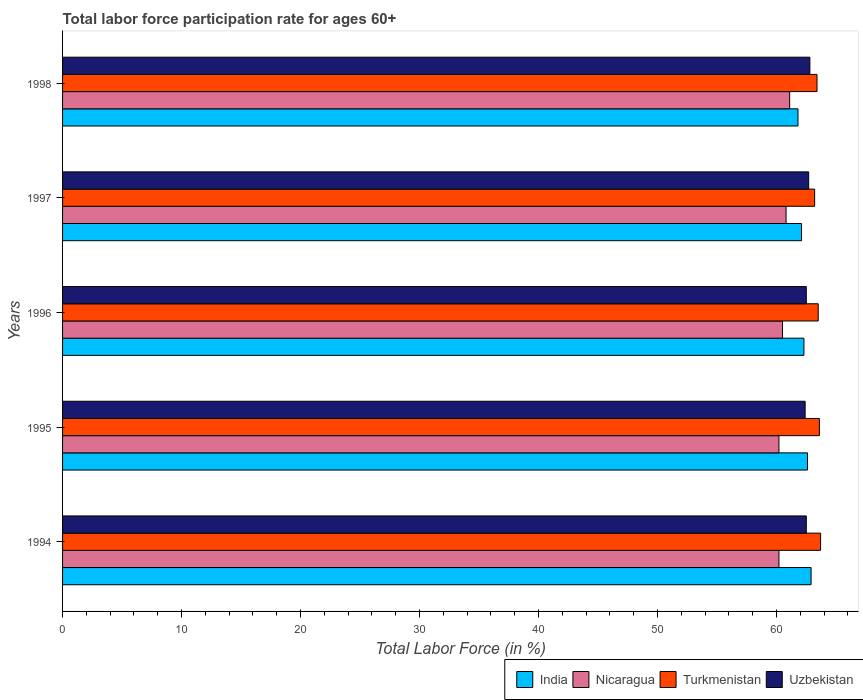How many different coloured bars are there?
Offer a terse response. 4. How many groups of bars are there?
Your answer should be compact. 5. Are the number of bars on each tick of the Y-axis equal?
Your answer should be very brief. Yes. What is the label of the 3rd group of bars from the top?
Give a very brief answer. 1996. In how many cases, is the number of bars for a given year not equal to the number of legend labels?
Your answer should be compact. 0. What is the labor force participation rate in Uzbekistan in 1996?
Offer a very short reply. 62.5. Across all years, what is the maximum labor force participation rate in India?
Your response must be concise. 62.9. Across all years, what is the minimum labor force participation rate in India?
Provide a short and direct response. 61.8. In which year was the labor force participation rate in Nicaragua maximum?
Ensure brevity in your answer.  1998. In which year was the labor force participation rate in Uzbekistan minimum?
Keep it short and to the point. 1995. What is the total labor force participation rate in India in the graph?
Make the answer very short. 311.7. What is the difference between the labor force participation rate in Uzbekistan in 1994 and that in 1995?
Keep it short and to the point. 0.1. What is the difference between the labor force participation rate in Nicaragua in 1996 and the labor force participation rate in Turkmenistan in 1998?
Make the answer very short. -2.9. What is the average labor force participation rate in Uzbekistan per year?
Keep it short and to the point. 62.58. In the year 1995, what is the difference between the labor force participation rate in Uzbekistan and labor force participation rate in Nicaragua?
Give a very brief answer. 2.2. In how many years, is the labor force participation rate in India greater than 56 %?
Give a very brief answer. 5. What is the ratio of the labor force participation rate in Nicaragua in 1994 to that in 1997?
Make the answer very short. 0.99. Is the labor force participation rate in India in 1995 less than that in 1997?
Keep it short and to the point. No. What is the difference between the highest and the second highest labor force participation rate in Uzbekistan?
Your response must be concise. 0.1. What is the difference between the highest and the lowest labor force participation rate in Uzbekistan?
Provide a succinct answer. 0.4. In how many years, is the labor force participation rate in India greater than the average labor force participation rate in India taken over all years?
Offer a very short reply. 2. What does the 1st bar from the top in 1994 represents?
Your answer should be compact. Uzbekistan. What does the 2nd bar from the bottom in 1995 represents?
Keep it short and to the point. Nicaragua. How many bars are there?
Your answer should be compact. 20. Does the graph contain grids?
Keep it short and to the point. No. Where does the legend appear in the graph?
Keep it short and to the point. Bottom right. How are the legend labels stacked?
Offer a terse response. Horizontal. What is the title of the graph?
Ensure brevity in your answer.  Total labor force participation rate for ages 60+. What is the label or title of the X-axis?
Keep it short and to the point. Total Labor Force (in %). What is the label or title of the Y-axis?
Your answer should be compact. Years. What is the Total Labor Force (in %) of India in 1994?
Your answer should be compact. 62.9. What is the Total Labor Force (in %) of Nicaragua in 1994?
Provide a short and direct response. 60.2. What is the Total Labor Force (in %) in Turkmenistan in 1994?
Your answer should be very brief. 63.7. What is the Total Labor Force (in %) of Uzbekistan in 1994?
Keep it short and to the point. 62.5. What is the Total Labor Force (in %) of India in 1995?
Your answer should be compact. 62.6. What is the Total Labor Force (in %) of Nicaragua in 1995?
Your answer should be very brief. 60.2. What is the Total Labor Force (in %) in Turkmenistan in 1995?
Provide a short and direct response. 63.6. What is the Total Labor Force (in %) of Uzbekistan in 1995?
Your answer should be compact. 62.4. What is the Total Labor Force (in %) in India in 1996?
Your answer should be very brief. 62.3. What is the Total Labor Force (in %) of Nicaragua in 1996?
Ensure brevity in your answer.  60.5. What is the Total Labor Force (in %) in Turkmenistan in 1996?
Give a very brief answer. 63.5. What is the Total Labor Force (in %) in Uzbekistan in 1996?
Give a very brief answer. 62.5. What is the Total Labor Force (in %) in India in 1997?
Your answer should be compact. 62.1. What is the Total Labor Force (in %) of Nicaragua in 1997?
Your answer should be very brief. 60.8. What is the Total Labor Force (in %) of Turkmenistan in 1997?
Your answer should be compact. 63.2. What is the Total Labor Force (in %) of Uzbekistan in 1997?
Your answer should be compact. 62.7. What is the Total Labor Force (in %) of India in 1998?
Offer a terse response. 61.8. What is the Total Labor Force (in %) of Nicaragua in 1998?
Give a very brief answer. 61.1. What is the Total Labor Force (in %) of Turkmenistan in 1998?
Make the answer very short. 63.4. What is the Total Labor Force (in %) in Uzbekistan in 1998?
Your answer should be very brief. 62.8. Across all years, what is the maximum Total Labor Force (in %) in India?
Ensure brevity in your answer.  62.9. Across all years, what is the maximum Total Labor Force (in %) of Nicaragua?
Make the answer very short. 61.1. Across all years, what is the maximum Total Labor Force (in %) of Turkmenistan?
Your response must be concise. 63.7. Across all years, what is the maximum Total Labor Force (in %) of Uzbekistan?
Your response must be concise. 62.8. Across all years, what is the minimum Total Labor Force (in %) of India?
Give a very brief answer. 61.8. Across all years, what is the minimum Total Labor Force (in %) of Nicaragua?
Your response must be concise. 60.2. Across all years, what is the minimum Total Labor Force (in %) of Turkmenistan?
Give a very brief answer. 63.2. Across all years, what is the minimum Total Labor Force (in %) of Uzbekistan?
Keep it short and to the point. 62.4. What is the total Total Labor Force (in %) in India in the graph?
Offer a terse response. 311.7. What is the total Total Labor Force (in %) in Nicaragua in the graph?
Your answer should be very brief. 302.8. What is the total Total Labor Force (in %) in Turkmenistan in the graph?
Ensure brevity in your answer.  317.4. What is the total Total Labor Force (in %) of Uzbekistan in the graph?
Keep it short and to the point. 312.9. What is the difference between the Total Labor Force (in %) of Nicaragua in 1994 and that in 1995?
Your answer should be compact. 0. What is the difference between the Total Labor Force (in %) in Uzbekistan in 1994 and that in 1995?
Your answer should be compact. 0.1. What is the difference between the Total Labor Force (in %) of Nicaragua in 1994 and that in 1996?
Offer a terse response. -0.3. What is the difference between the Total Labor Force (in %) of Turkmenistan in 1994 and that in 1996?
Offer a terse response. 0.2. What is the difference between the Total Labor Force (in %) in Uzbekistan in 1994 and that in 1996?
Your answer should be compact. 0. What is the difference between the Total Labor Force (in %) in India in 1994 and that in 1997?
Give a very brief answer. 0.8. What is the difference between the Total Labor Force (in %) in Nicaragua in 1994 and that in 1997?
Offer a very short reply. -0.6. What is the difference between the Total Labor Force (in %) of Turkmenistan in 1994 and that in 1997?
Your response must be concise. 0.5. What is the difference between the Total Labor Force (in %) of Turkmenistan in 1994 and that in 1998?
Your answer should be very brief. 0.3. What is the difference between the Total Labor Force (in %) of Uzbekistan in 1994 and that in 1998?
Offer a terse response. -0.3. What is the difference between the Total Labor Force (in %) of India in 1995 and that in 1996?
Offer a very short reply. 0.3. What is the difference between the Total Labor Force (in %) of Nicaragua in 1995 and that in 1996?
Your response must be concise. -0.3. What is the difference between the Total Labor Force (in %) in Uzbekistan in 1995 and that in 1996?
Provide a short and direct response. -0.1. What is the difference between the Total Labor Force (in %) in India in 1995 and that in 1997?
Offer a terse response. 0.5. What is the difference between the Total Labor Force (in %) of Nicaragua in 1995 and that in 1997?
Your answer should be compact. -0.6. What is the difference between the Total Labor Force (in %) of Turkmenistan in 1995 and that in 1997?
Your response must be concise. 0.4. What is the difference between the Total Labor Force (in %) of India in 1995 and that in 1998?
Offer a very short reply. 0.8. What is the difference between the Total Labor Force (in %) in Turkmenistan in 1995 and that in 1998?
Keep it short and to the point. 0.2. What is the difference between the Total Labor Force (in %) of Uzbekistan in 1995 and that in 1998?
Offer a terse response. -0.4. What is the difference between the Total Labor Force (in %) in Uzbekistan in 1996 and that in 1997?
Provide a succinct answer. -0.2. What is the difference between the Total Labor Force (in %) of Uzbekistan in 1997 and that in 1998?
Provide a short and direct response. -0.1. What is the difference between the Total Labor Force (in %) in Nicaragua in 1994 and the Total Labor Force (in %) in Turkmenistan in 1995?
Your answer should be very brief. -3.4. What is the difference between the Total Labor Force (in %) in Turkmenistan in 1994 and the Total Labor Force (in %) in Uzbekistan in 1995?
Make the answer very short. 1.3. What is the difference between the Total Labor Force (in %) of India in 1994 and the Total Labor Force (in %) of Uzbekistan in 1996?
Offer a terse response. 0.4. What is the difference between the Total Labor Force (in %) in Turkmenistan in 1994 and the Total Labor Force (in %) in Uzbekistan in 1996?
Offer a very short reply. 1.2. What is the difference between the Total Labor Force (in %) in India in 1994 and the Total Labor Force (in %) in Nicaragua in 1997?
Keep it short and to the point. 2.1. What is the difference between the Total Labor Force (in %) in India in 1994 and the Total Labor Force (in %) in Turkmenistan in 1997?
Make the answer very short. -0.3. What is the difference between the Total Labor Force (in %) in Nicaragua in 1994 and the Total Labor Force (in %) in Uzbekistan in 1997?
Keep it short and to the point. -2.5. What is the difference between the Total Labor Force (in %) of Turkmenistan in 1994 and the Total Labor Force (in %) of Uzbekistan in 1997?
Ensure brevity in your answer.  1. What is the difference between the Total Labor Force (in %) in India in 1994 and the Total Labor Force (in %) in Turkmenistan in 1998?
Your answer should be very brief. -0.5. What is the difference between the Total Labor Force (in %) of India in 1995 and the Total Labor Force (in %) of Uzbekistan in 1996?
Make the answer very short. 0.1. What is the difference between the Total Labor Force (in %) of Nicaragua in 1995 and the Total Labor Force (in %) of Turkmenistan in 1996?
Provide a short and direct response. -3.3. What is the difference between the Total Labor Force (in %) of Turkmenistan in 1995 and the Total Labor Force (in %) of Uzbekistan in 1996?
Your answer should be very brief. 1.1. What is the difference between the Total Labor Force (in %) of India in 1995 and the Total Labor Force (in %) of Nicaragua in 1998?
Provide a succinct answer. 1.5. What is the difference between the Total Labor Force (in %) of Nicaragua in 1995 and the Total Labor Force (in %) of Turkmenistan in 1998?
Give a very brief answer. -3.2. What is the difference between the Total Labor Force (in %) of Turkmenistan in 1995 and the Total Labor Force (in %) of Uzbekistan in 1998?
Your answer should be compact. 0.8. What is the difference between the Total Labor Force (in %) of India in 1996 and the Total Labor Force (in %) of Uzbekistan in 1997?
Your response must be concise. -0.4. What is the difference between the Total Labor Force (in %) in Nicaragua in 1996 and the Total Labor Force (in %) in Turkmenistan in 1997?
Ensure brevity in your answer.  -2.7. What is the difference between the Total Labor Force (in %) in Turkmenistan in 1996 and the Total Labor Force (in %) in Uzbekistan in 1997?
Provide a succinct answer. 0.8. What is the difference between the Total Labor Force (in %) of India in 1996 and the Total Labor Force (in %) of Nicaragua in 1998?
Ensure brevity in your answer.  1.2. What is the difference between the Total Labor Force (in %) in India in 1996 and the Total Labor Force (in %) in Turkmenistan in 1998?
Give a very brief answer. -1.1. What is the difference between the Total Labor Force (in %) in Nicaragua in 1996 and the Total Labor Force (in %) in Turkmenistan in 1998?
Offer a very short reply. -2.9. What is the difference between the Total Labor Force (in %) of India in 1997 and the Total Labor Force (in %) of Turkmenistan in 1998?
Keep it short and to the point. -1.3. What is the difference between the Total Labor Force (in %) in India in 1997 and the Total Labor Force (in %) in Uzbekistan in 1998?
Your answer should be very brief. -0.7. What is the difference between the Total Labor Force (in %) of Nicaragua in 1997 and the Total Labor Force (in %) of Turkmenistan in 1998?
Your answer should be compact. -2.6. What is the difference between the Total Labor Force (in %) of Turkmenistan in 1997 and the Total Labor Force (in %) of Uzbekistan in 1998?
Your answer should be compact. 0.4. What is the average Total Labor Force (in %) in India per year?
Provide a short and direct response. 62.34. What is the average Total Labor Force (in %) of Nicaragua per year?
Keep it short and to the point. 60.56. What is the average Total Labor Force (in %) of Turkmenistan per year?
Your response must be concise. 63.48. What is the average Total Labor Force (in %) in Uzbekistan per year?
Your response must be concise. 62.58. In the year 1994, what is the difference between the Total Labor Force (in %) of India and Total Labor Force (in %) of Nicaragua?
Keep it short and to the point. 2.7. In the year 1994, what is the difference between the Total Labor Force (in %) of Turkmenistan and Total Labor Force (in %) of Uzbekistan?
Ensure brevity in your answer.  1.2. In the year 1995, what is the difference between the Total Labor Force (in %) in India and Total Labor Force (in %) in Uzbekistan?
Your response must be concise. 0.2. In the year 1995, what is the difference between the Total Labor Force (in %) in Turkmenistan and Total Labor Force (in %) in Uzbekistan?
Offer a terse response. 1.2. In the year 1996, what is the difference between the Total Labor Force (in %) of India and Total Labor Force (in %) of Nicaragua?
Your answer should be compact. 1.8. In the year 1996, what is the difference between the Total Labor Force (in %) in Nicaragua and Total Labor Force (in %) in Uzbekistan?
Offer a terse response. -2. In the year 1997, what is the difference between the Total Labor Force (in %) in India and Total Labor Force (in %) in Nicaragua?
Your response must be concise. 1.3. In the year 1997, what is the difference between the Total Labor Force (in %) of India and Total Labor Force (in %) of Uzbekistan?
Your answer should be very brief. -0.6. In the year 1998, what is the difference between the Total Labor Force (in %) in India and Total Labor Force (in %) in Turkmenistan?
Provide a short and direct response. -1.6. In the year 1998, what is the difference between the Total Labor Force (in %) of India and Total Labor Force (in %) of Uzbekistan?
Provide a succinct answer. -1. In the year 1998, what is the difference between the Total Labor Force (in %) of Nicaragua and Total Labor Force (in %) of Turkmenistan?
Provide a succinct answer. -2.3. In the year 1998, what is the difference between the Total Labor Force (in %) in Nicaragua and Total Labor Force (in %) in Uzbekistan?
Ensure brevity in your answer.  -1.7. What is the ratio of the Total Labor Force (in %) of Nicaragua in 1994 to that in 1995?
Ensure brevity in your answer.  1. What is the ratio of the Total Labor Force (in %) in India in 1994 to that in 1996?
Your response must be concise. 1.01. What is the ratio of the Total Labor Force (in %) in Turkmenistan in 1994 to that in 1996?
Keep it short and to the point. 1. What is the ratio of the Total Labor Force (in %) of Uzbekistan in 1994 to that in 1996?
Give a very brief answer. 1. What is the ratio of the Total Labor Force (in %) of India in 1994 to that in 1997?
Offer a terse response. 1.01. What is the ratio of the Total Labor Force (in %) of Turkmenistan in 1994 to that in 1997?
Your answer should be very brief. 1.01. What is the ratio of the Total Labor Force (in %) in India in 1994 to that in 1998?
Provide a succinct answer. 1.02. What is the ratio of the Total Labor Force (in %) in Turkmenistan in 1994 to that in 1998?
Make the answer very short. 1. What is the ratio of the Total Labor Force (in %) in India in 1995 to that in 1996?
Ensure brevity in your answer.  1. What is the ratio of the Total Labor Force (in %) in Nicaragua in 1995 to that in 1996?
Your response must be concise. 0.99. What is the ratio of the Total Labor Force (in %) of Turkmenistan in 1995 to that in 1996?
Offer a very short reply. 1. What is the ratio of the Total Labor Force (in %) of Turkmenistan in 1995 to that in 1997?
Ensure brevity in your answer.  1.01. What is the ratio of the Total Labor Force (in %) of India in 1995 to that in 1998?
Offer a very short reply. 1.01. What is the ratio of the Total Labor Force (in %) in Nicaragua in 1996 to that in 1997?
Provide a short and direct response. 1. What is the ratio of the Total Labor Force (in %) in Nicaragua in 1996 to that in 1998?
Keep it short and to the point. 0.99. What is the ratio of the Total Labor Force (in %) of Turkmenistan in 1996 to that in 1998?
Provide a short and direct response. 1. What is the ratio of the Total Labor Force (in %) in Uzbekistan in 1996 to that in 1998?
Ensure brevity in your answer.  1. What is the ratio of the Total Labor Force (in %) in Nicaragua in 1997 to that in 1998?
Offer a terse response. 1. What is the ratio of the Total Labor Force (in %) in Uzbekistan in 1997 to that in 1998?
Offer a terse response. 1. What is the difference between the highest and the second highest Total Labor Force (in %) in Turkmenistan?
Offer a terse response. 0.1. What is the difference between the highest and the second highest Total Labor Force (in %) of Uzbekistan?
Offer a terse response. 0.1. What is the difference between the highest and the lowest Total Labor Force (in %) in India?
Offer a terse response. 1.1. What is the difference between the highest and the lowest Total Labor Force (in %) in Nicaragua?
Give a very brief answer. 0.9. What is the difference between the highest and the lowest Total Labor Force (in %) of Uzbekistan?
Offer a terse response. 0.4. 